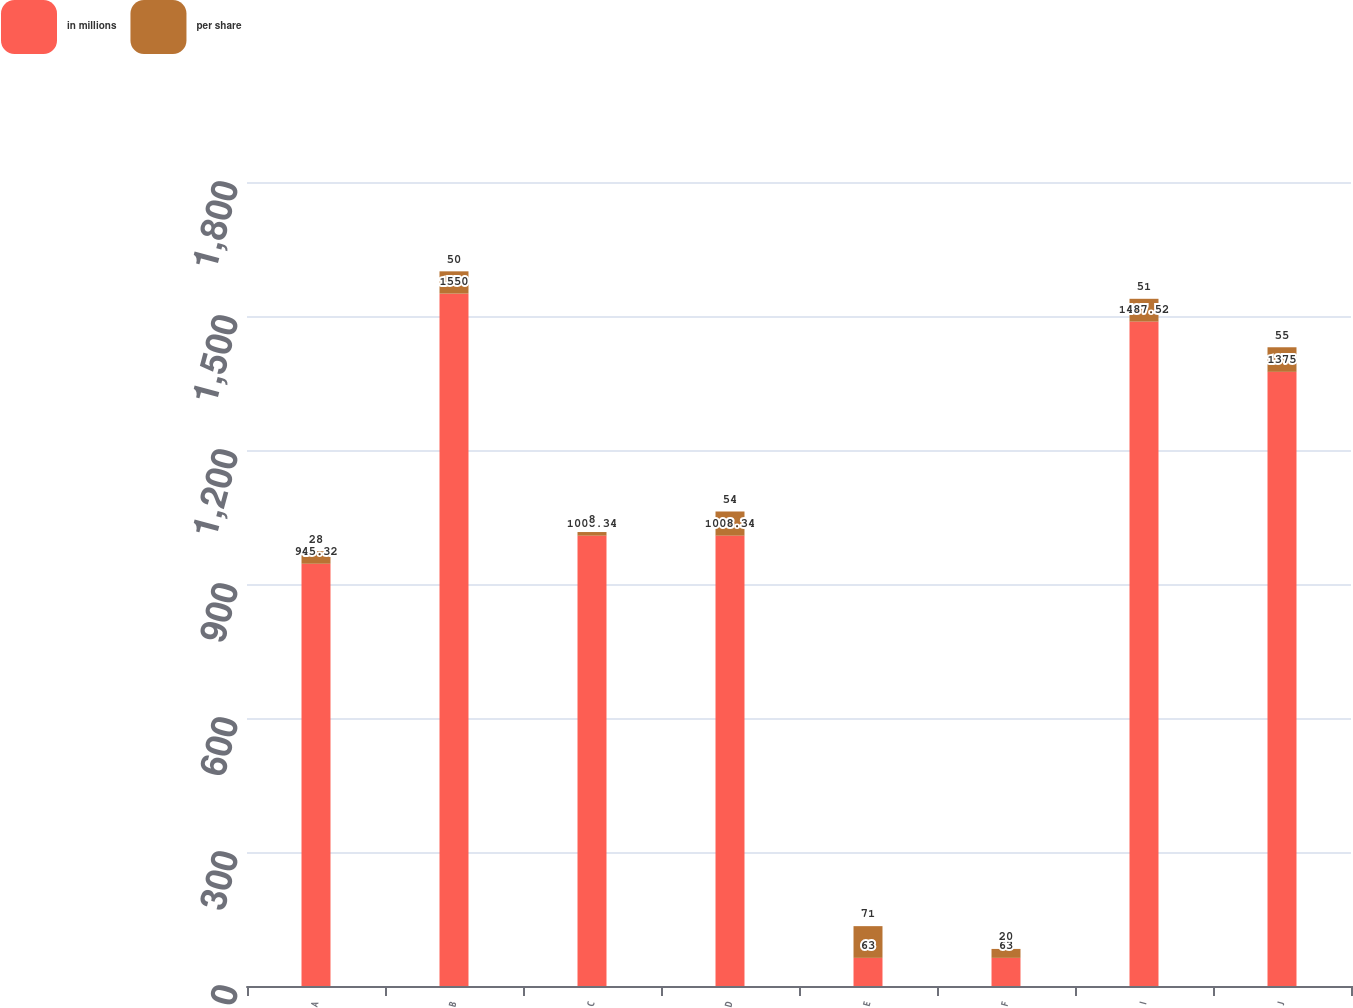Convert chart. <chart><loc_0><loc_0><loc_500><loc_500><stacked_bar_chart><ecel><fcel>A<fcel>B<fcel>C<fcel>D<fcel>E<fcel>F<fcel>I<fcel>J<nl><fcel>in millions<fcel>945.32<fcel>1550<fcel>1008.34<fcel>1008.34<fcel>63<fcel>63<fcel>1487.52<fcel>1375<nl><fcel>per share<fcel>28<fcel>50<fcel>8<fcel>54<fcel>71<fcel>20<fcel>51<fcel>55<nl></chart> 